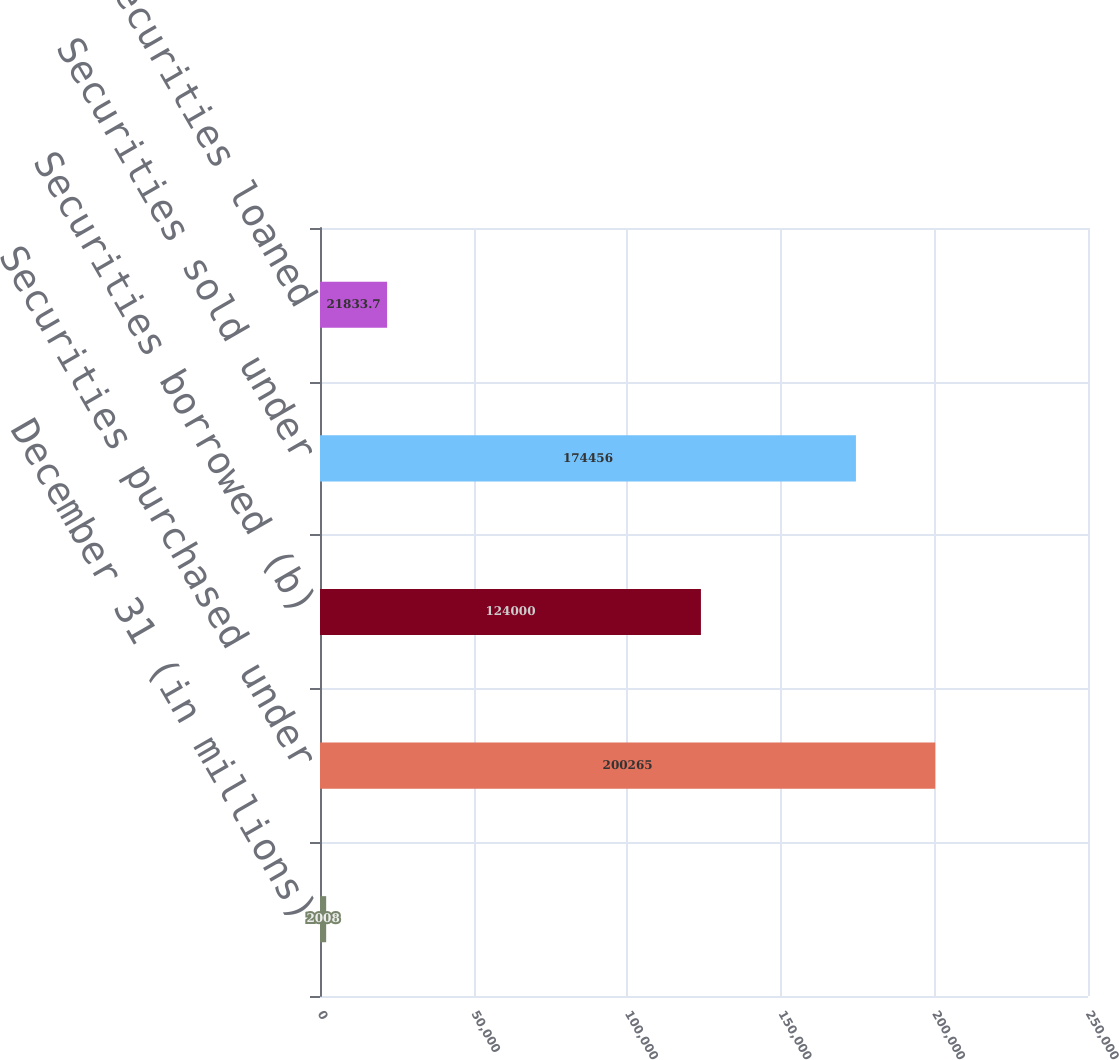Convert chart. <chart><loc_0><loc_0><loc_500><loc_500><bar_chart><fcel>December 31 (in millions)<fcel>Securities purchased under<fcel>Securities borrowed (b)<fcel>Securities sold under<fcel>Securities loaned<nl><fcel>2008<fcel>200265<fcel>124000<fcel>174456<fcel>21833.7<nl></chart> 